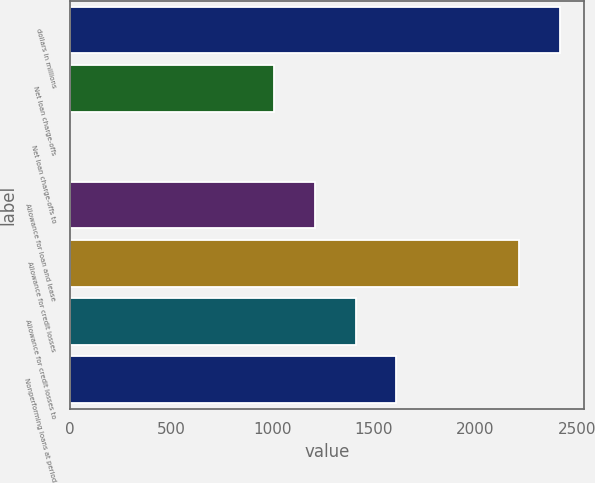Convert chart. <chart><loc_0><loc_0><loc_500><loc_500><bar_chart><fcel>dollars in millions<fcel>Net loan charge-offs<fcel>Net loan charge-offs to<fcel>Allowance for loan and lease<fcel>Allowance for credit losses<fcel>Allowance for credit losses to<fcel>Nonperforming loans at period<nl><fcel>2416.76<fcel>1007.1<fcel>0.2<fcel>1208.48<fcel>2215.38<fcel>1409.86<fcel>1611.24<nl></chart> 